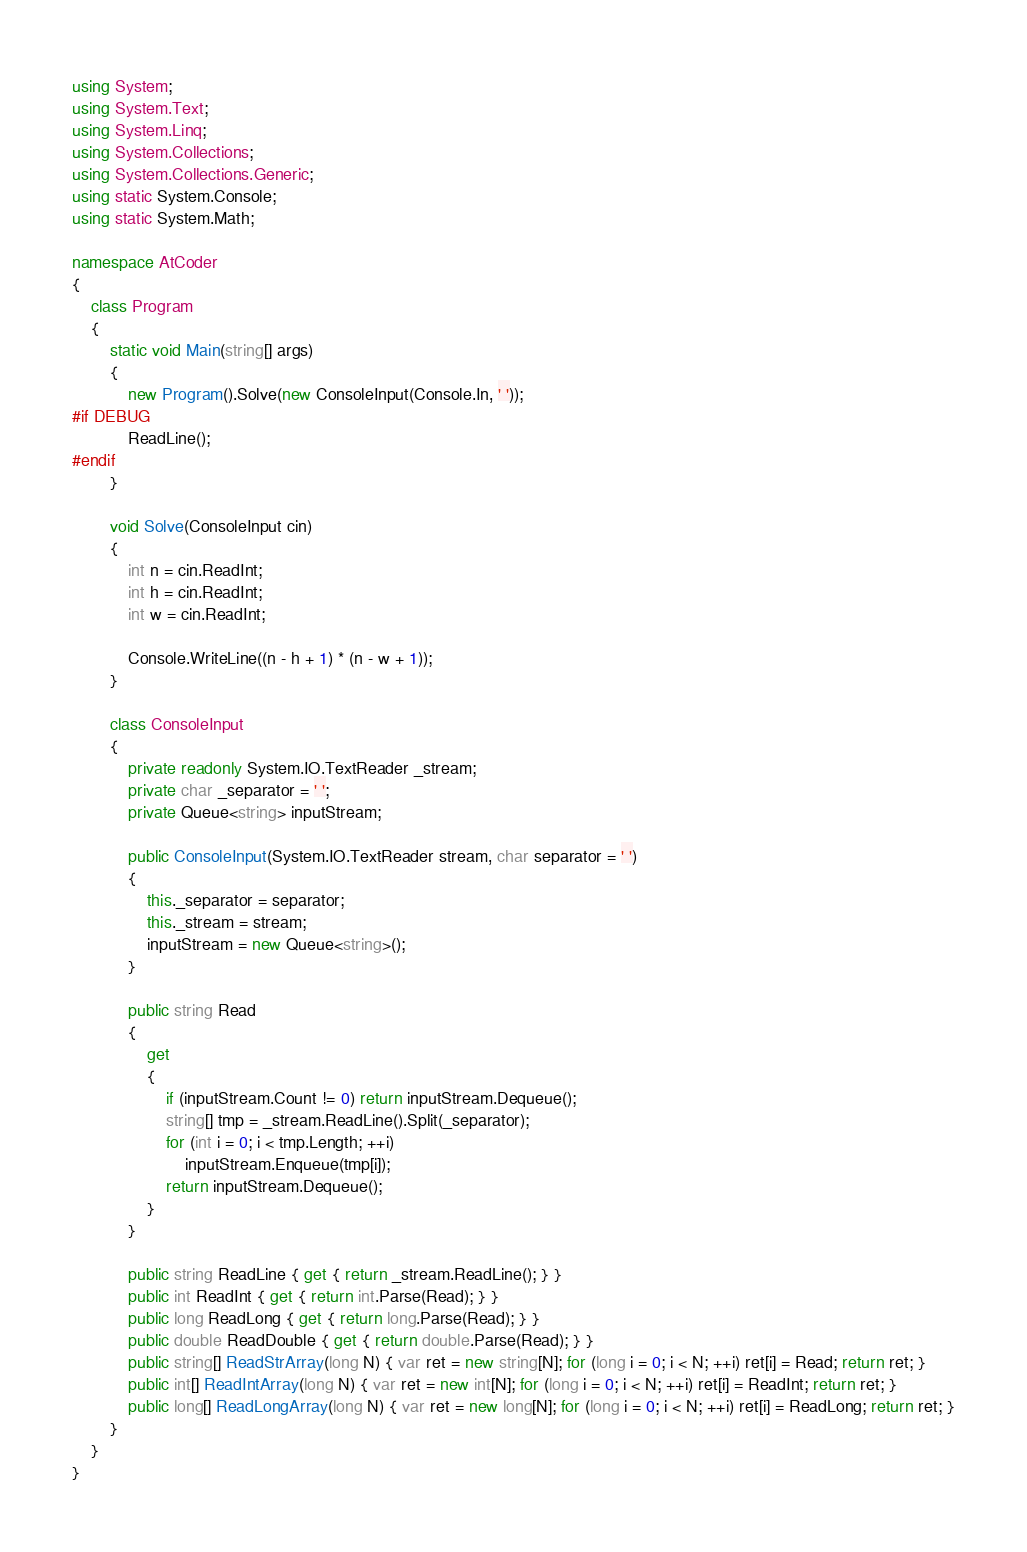<code> <loc_0><loc_0><loc_500><loc_500><_C#_>using System;
using System.Text;
using System.Linq;
using System.Collections;
using System.Collections.Generic;
using static System.Console;
using static System.Math;

namespace AtCoder
{
    class Program
    {
        static void Main(string[] args)
        {
            new Program().Solve(new ConsoleInput(Console.In, ' '));
#if DEBUG
            ReadLine();
#endif
        }

        void Solve(ConsoleInput cin)
        {
            int n = cin.ReadInt;
            int h = cin.ReadInt;
            int w = cin.ReadInt;

            Console.WriteLine((n - h + 1) * (n - w + 1));
        }

        class ConsoleInput
        {
            private readonly System.IO.TextReader _stream;
            private char _separator = ' ';
            private Queue<string> inputStream;

            public ConsoleInput(System.IO.TextReader stream, char separator = ' ')
            {
                this._separator = separator;
                this._stream = stream;
                inputStream = new Queue<string>();
            }

            public string Read
            {
                get
                {
                    if (inputStream.Count != 0) return inputStream.Dequeue();
                    string[] tmp = _stream.ReadLine().Split(_separator);
                    for (int i = 0; i < tmp.Length; ++i)
                        inputStream.Enqueue(tmp[i]);
                    return inputStream.Dequeue();
                }
            }

            public string ReadLine { get { return _stream.ReadLine(); } }
            public int ReadInt { get { return int.Parse(Read); } }
            public long ReadLong { get { return long.Parse(Read); } }
            public double ReadDouble { get { return double.Parse(Read); } }
            public string[] ReadStrArray(long N) { var ret = new string[N]; for (long i = 0; i < N; ++i) ret[i] = Read; return ret; }
            public int[] ReadIntArray(long N) { var ret = new int[N]; for (long i = 0; i < N; ++i) ret[i] = ReadInt; return ret; }
            public long[] ReadLongArray(long N) { var ret = new long[N]; for (long i = 0; i < N; ++i) ret[i] = ReadLong; return ret; }
        }
    }
}
</code> 